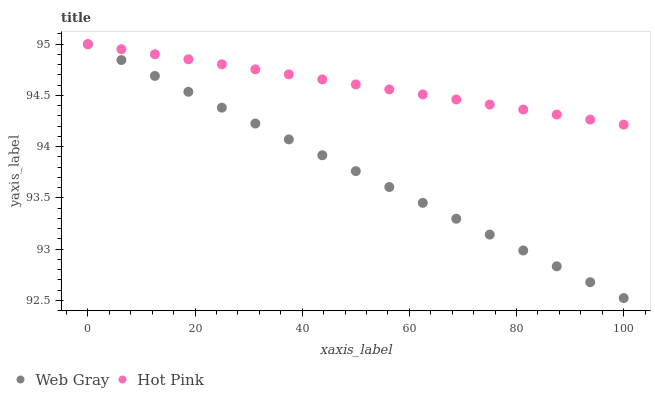Does Web Gray have the minimum area under the curve?
Answer yes or no. Yes. Does Hot Pink have the maximum area under the curve?
Answer yes or no. Yes. Does Hot Pink have the minimum area under the curve?
Answer yes or no. No. Is Web Gray the smoothest?
Answer yes or no. Yes. Is Hot Pink the roughest?
Answer yes or no. Yes. Is Hot Pink the smoothest?
Answer yes or no. No. Does Web Gray have the lowest value?
Answer yes or no. Yes. Does Hot Pink have the lowest value?
Answer yes or no. No. Does Hot Pink have the highest value?
Answer yes or no. Yes. Does Hot Pink intersect Web Gray?
Answer yes or no. Yes. Is Hot Pink less than Web Gray?
Answer yes or no. No. Is Hot Pink greater than Web Gray?
Answer yes or no. No. 